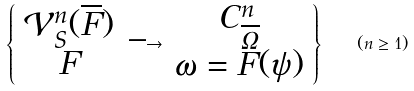<formula> <loc_0><loc_0><loc_500><loc_500>\left \{ \begin{array} { c } \mathcal { V } _ { S } ^ { n } ( \overline { F } ) \\ F \end{array} \longrightarrow \begin{array} { c } C ^ { n } _ { \overline { \Omega } } \\ \omega = F ( \psi ) \end{array} \right \} \quad ( n \geq 1 )</formula> 